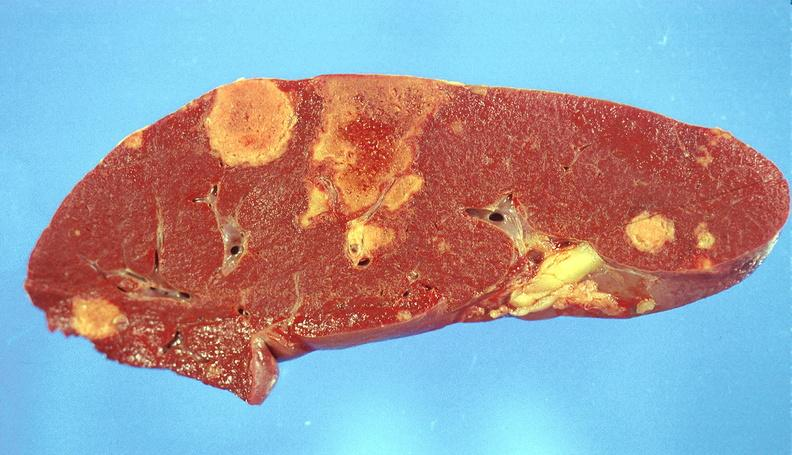s pulmonary osteoarthropathy present?
Answer the question using a single word or phrase. No 